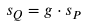Convert formula to latex. <formula><loc_0><loc_0><loc_500><loc_500>s _ { Q } = g \cdot s _ { P }</formula> 